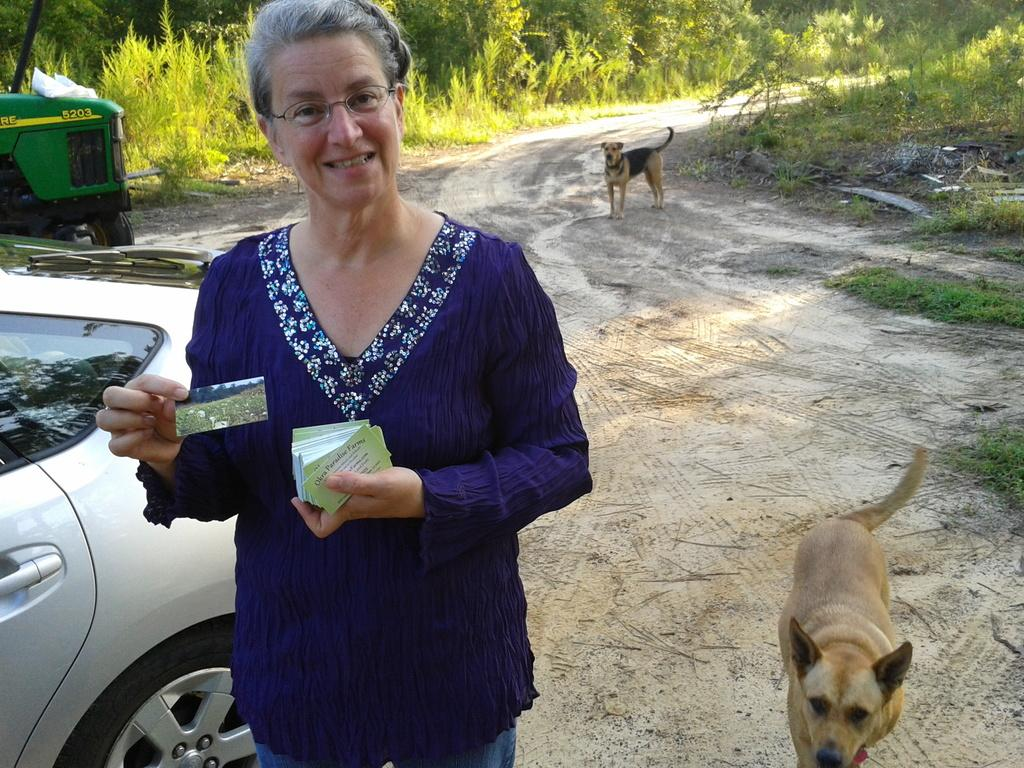Who is present in the image? There is a woman in the image. What is the woman wearing? The woman is wearing a blue dress. What is the woman holding in the image? The woman is holding cards. What can be seen on the left side of the image? There are vehicles on the left side of the image. What animals are present in the image? There are dogs in the image. What type of vegetation is visible in the image? There are trees in the image. What type of oatmeal is being served in the image? There is no oatmeal present in the image. What sound does the alarm make in the image? There is no alarm present in the image. 